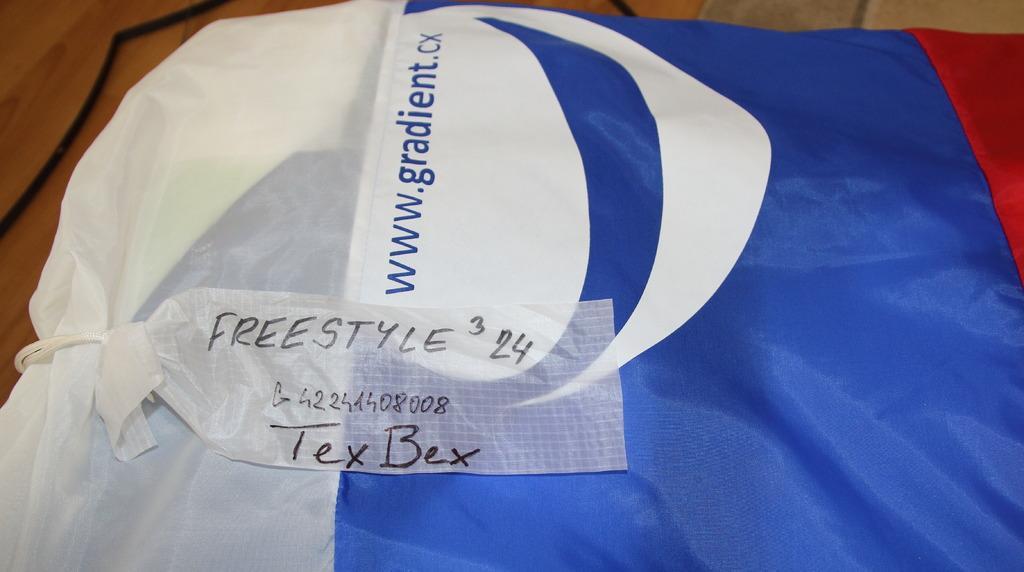How would you summarize this image in a sentence or two? In this image there is a costume with the label on it which was placed on the table. 